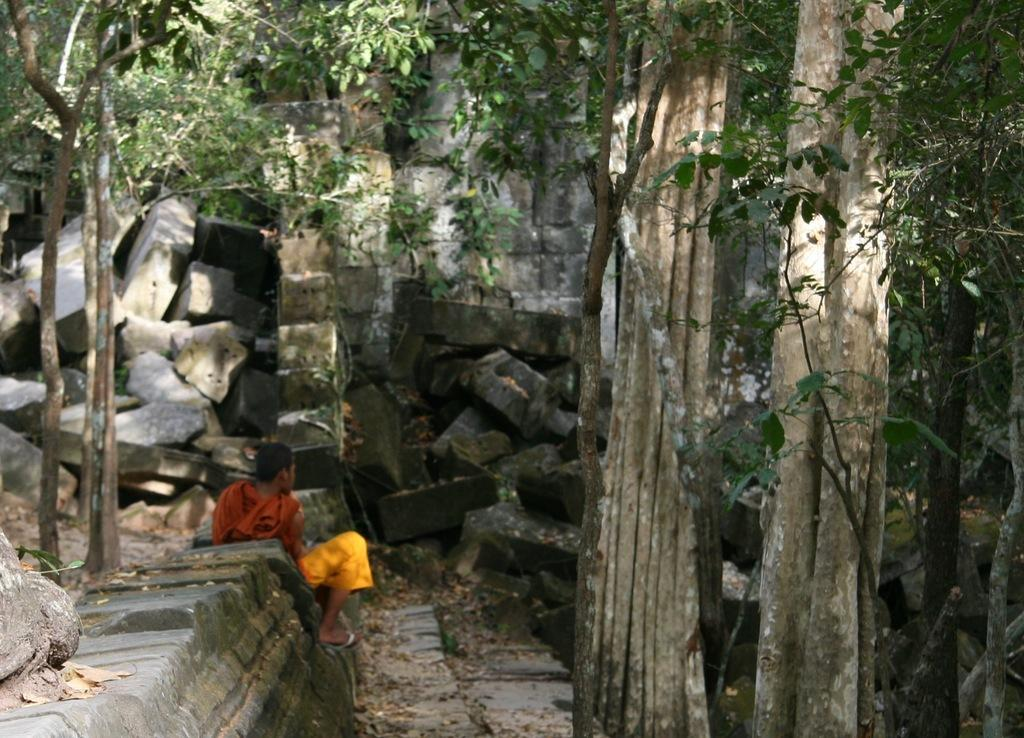What is the person in the image doing? The person is sitting on a rock in the image. What else can be seen in the image besides the person? There are other rocks and trees visible in the image. Are there any plants in the image? Yes, there are plants in the image. What reason does the person have for using a hammer in the image? There is no hammer present in the image, so it is not possible to determine a reason for using one. 